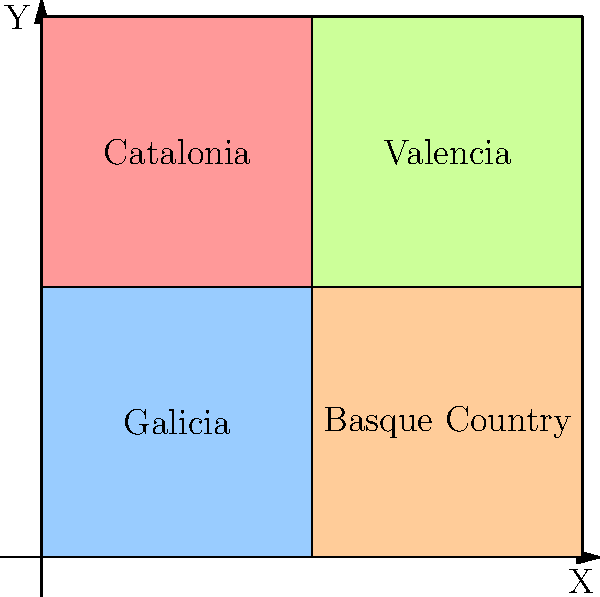In the given map of Spain's linguistic regions, which coordinate point $(x,y)$ represents the approximate center of the area where Catalan is predominantly spoken? To answer this question, we need to analyze the color-coded map of Spain's linguistic regions:

1. The map is divided into four quadrants, each representing a different linguistic region.
2. The coordinate system ranges from 0 to 100 on both x and y axes.
3. Catalonia, where Catalan is predominantly spoken, is represented by the red-colored quadrant.
4. The Catalan-speaking region is located in the upper-left quadrant of the map.
5. To find the approximate center of this region, we need to identify the middle point of the quadrant.
6. The Catalan region extends from x=0 to x=50 and from y=50 to y=100.
7. The center point would be halfway between these coordinates.
8. For the x-coordinate: $(0 + 50) / 2 = 25$
9. For the y-coordinate: $(50 + 100) / 2 = 75$

Therefore, the approximate center of the Catalan-speaking region is at the coordinate point $(25, 75)$.
Answer: $(25, 75)$ 